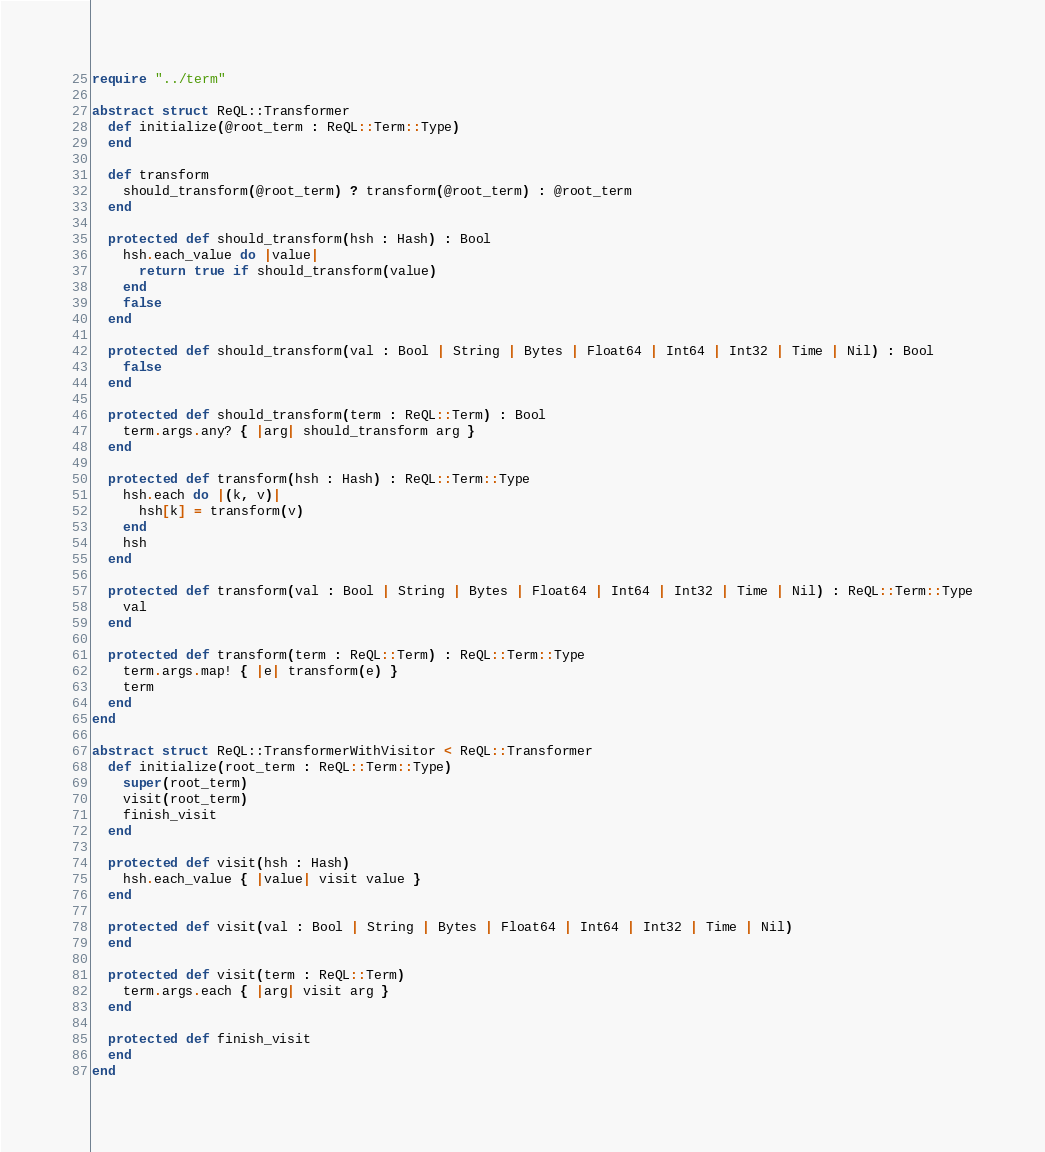<code> <loc_0><loc_0><loc_500><loc_500><_Crystal_>require "../term"

abstract struct ReQL::Transformer
  def initialize(@root_term : ReQL::Term::Type)
  end

  def transform
    should_transform(@root_term) ? transform(@root_term) : @root_term
  end

  protected def should_transform(hsh : Hash) : Bool
    hsh.each_value do |value|
      return true if should_transform(value)
    end
    false
  end

  protected def should_transform(val : Bool | String | Bytes | Float64 | Int64 | Int32 | Time | Nil) : Bool
    false
  end

  protected def should_transform(term : ReQL::Term) : Bool
    term.args.any? { |arg| should_transform arg }
  end

  protected def transform(hsh : Hash) : ReQL::Term::Type
    hsh.each do |(k, v)|
      hsh[k] = transform(v)
    end
    hsh
  end

  protected def transform(val : Bool | String | Bytes | Float64 | Int64 | Int32 | Time | Nil) : ReQL::Term::Type
    val
  end

  protected def transform(term : ReQL::Term) : ReQL::Term::Type
    term.args.map! { |e| transform(e) }
    term
  end
end

abstract struct ReQL::TransformerWithVisitor < ReQL::Transformer
  def initialize(root_term : ReQL::Term::Type)
    super(root_term)
    visit(root_term)
    finish_visit
  end

  protected def visit(hsh : Hash)
    hsh.each_value { |value| visit value }
  end

  protected def visit(val : Bool | String | Bytes | Float64 | Int64 | Int32 | Time | Nil)
  end

  protected def visit(term : ReQL::Term)
    term.args.each { |arg| visit arg }
  end

  protected def finish_visit
  end
end
</code> 